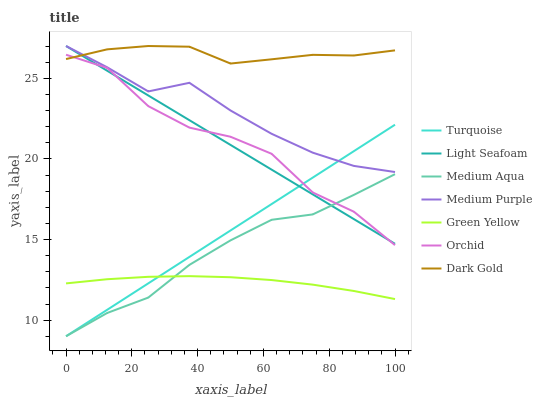Does Green Yellow have the minimum area under the curve?
Answer yes or no. Yes. Does Dark Gold have the maximum area under the curve?
Answer yes or no. Yes. Does Dark Gold have the minimum area under the curve?
Answer yes or no. No. Does Green Yellow have the maximum area under the curve?
Answer yes or no. No. Is Turquoise the smoothest?
Answer yes or no. Yes. Is Orchid the roughest?
Answer yes or no. Yes. Is Green Yellow the smoothest?
Answer yes or no. No. Is Green Yellow the roughest?
Answer yes or no. No. Does Turquoise have the lowest value?
Answer yes or no. Yes. Does Green Yellow have the lowest value?
Answer yes or no. No. Does Light Seafoam have the highest value?
Answer yes or no. Yes. Does Green Yellow have the highest value?
Answer yes or no. No. Is Green Yellow less than Orchid?
Answer yes or no. Yes. Is Dark Gold greater than Green Yellow?
Answer yes or no. Yes. Does Dark Gold intersect Light Seafoam?
Answer yes or no. Yes. Is Dark Gold less than Light Seafoam?
Answer yes or no. No. Is Dark Gold greater than Light Seafoam?
Answer yes or no. No. Does Green Yellow intersect Orchid?
Answer yes or no. No. 